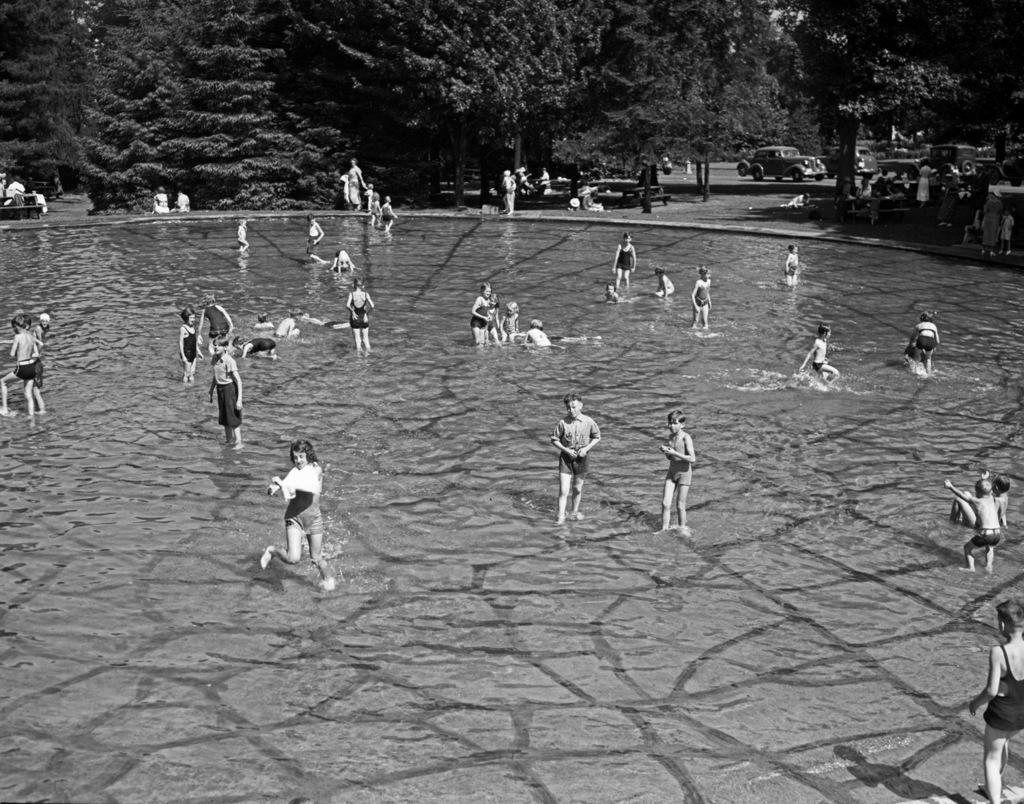What is the main feature in the foreground of the image? There is a swimming pool in the foreground of the image. What are the kids in the image doing? There are many kids in or around the swimming pool, suggesting they are swimming or playing. What can be seen in the background of the image? There are trees, other people, a bench, and a car in the background of the image. How many legs can be seen on the spy in the image? There is no spy present in the image, so it is not possible to determine the number of legs. 